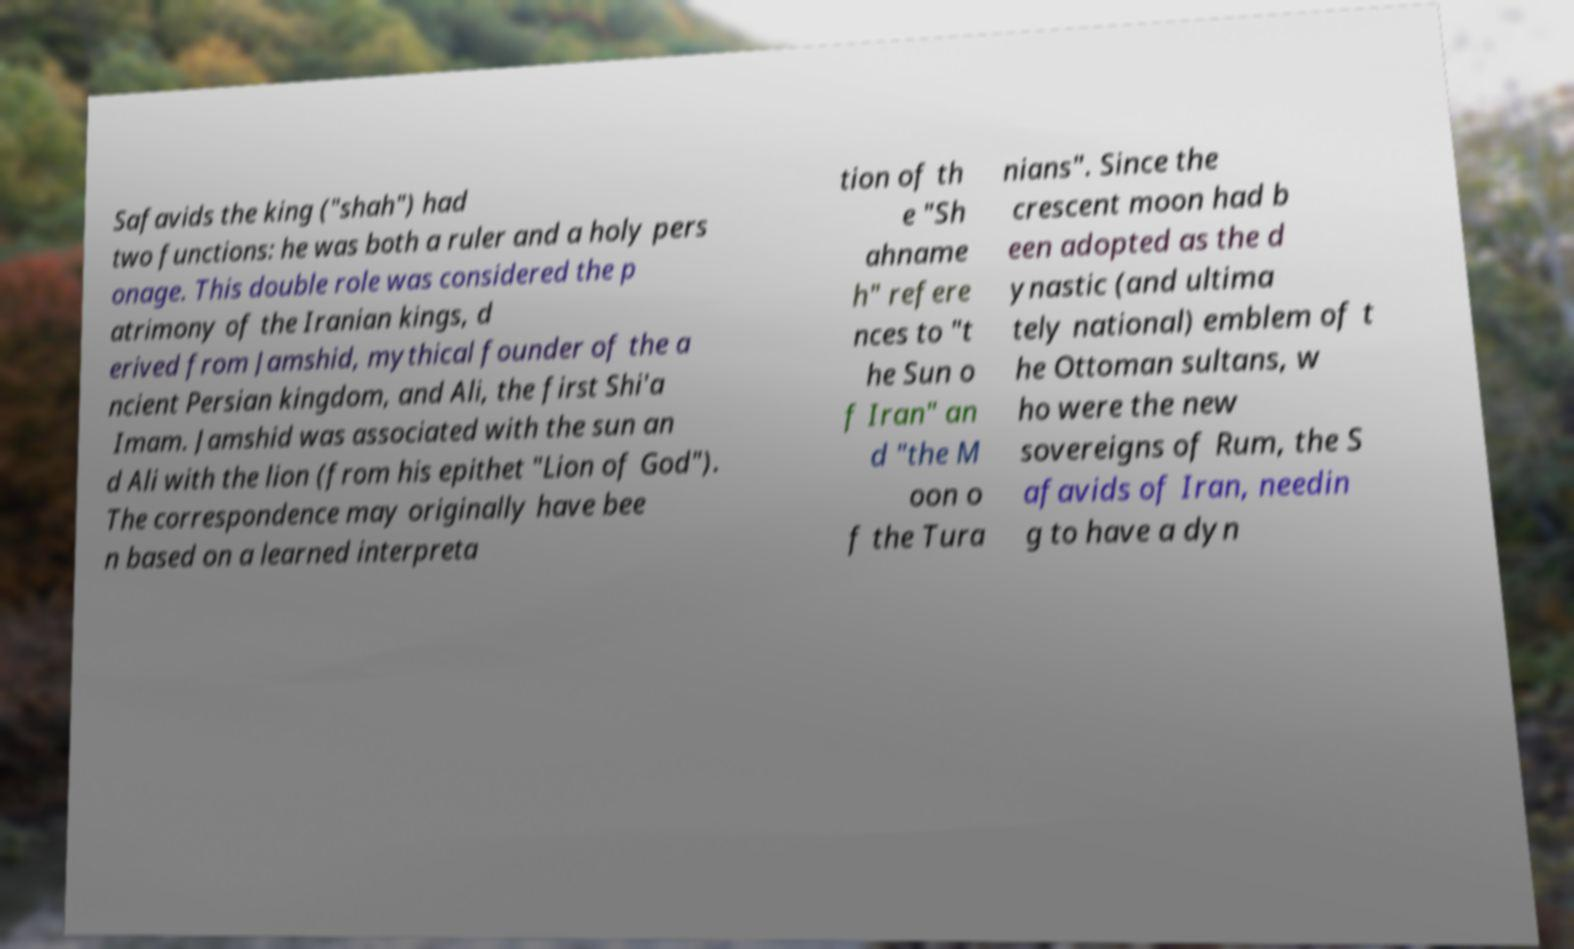For documentation purposes, I need the text within this image transcribed. Could you provide that? Safavids the king ("shah") had two functions: he was both a ruler and a holy pers onage. This double role was considered the p atrimony of the Iranian kings, d erived from Jamshid, mythical founder of the a ncient Persian kingdom, and Ali, the first Shi'a Imam. Jamshid was associated with the sun an d Ali with the lion (from his epithet "Lion of God"). The correspondence may originally have bee n based on a learned interpreta tion of th e "Sh ahname h" refere nces to "t he Sun o f Iran" an d "the M oon o f the Tura nians". Since the crescent moon had b een adopted as the d ynastic (and ultima tely national) emblem of t he Ottoman sultans, w ho were the new sovereigns of Rum, the S afavids of Iran, needin g to have a dyn 